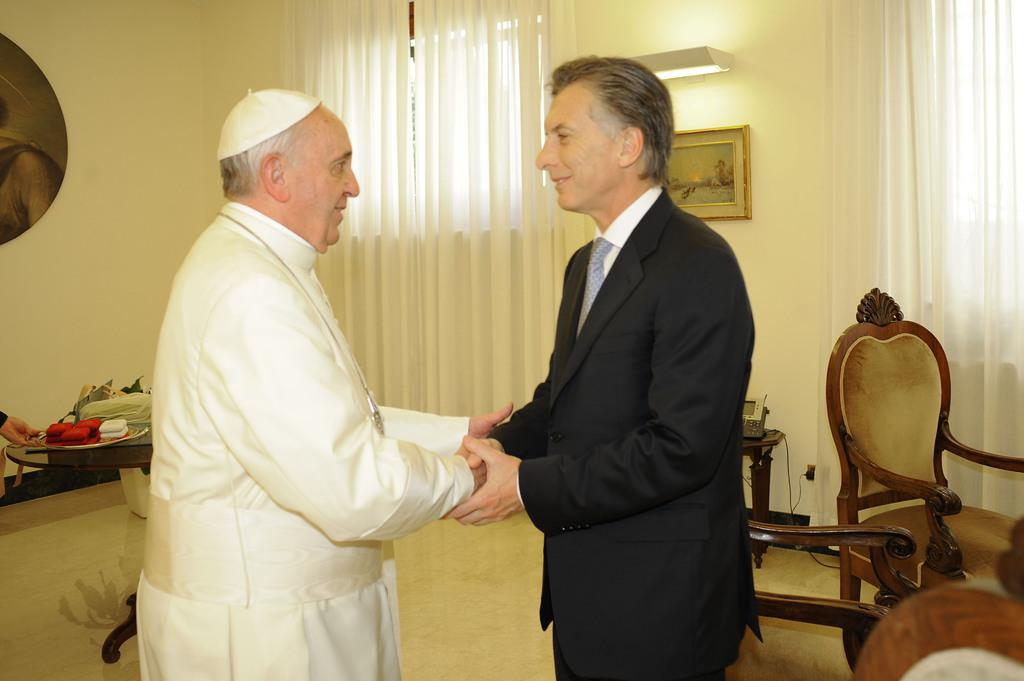How many people are present in the image? There are two persons standing in the image. What can be seen in the background of the image? There is a frame attached to the wall, a chair, a curtain, and a table in the background. Can you describe the objects in the background? The frame is attached to the wall, there is a chair, a curtain, and a table in the background. What is the price of the quilt hanging on the wall in the image? There is no quilt present in the image, so it is not possible to determine its price. 